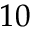<formula> <loc_0><loc_0><loc_500><loc_500>1 0</formula> 